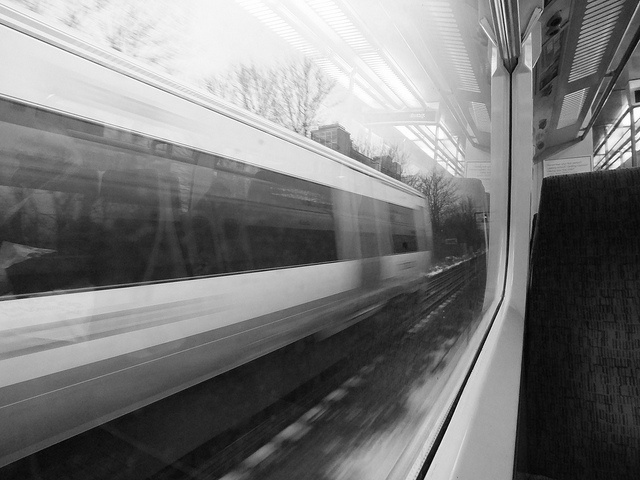Describe the objects in this image and their specific colors. I can see train in lightgray, black, darkgray, and gray tones, train in lightgray, gray, darkgray, and black tones, and chair in black and lightgray tones in this image. 